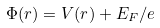Convert formula to latex. <formula><loc_0><loc_0><loc_500><loc_500>\Phi ( r ) = V ( r ) + E _ { F } / e</formula> 